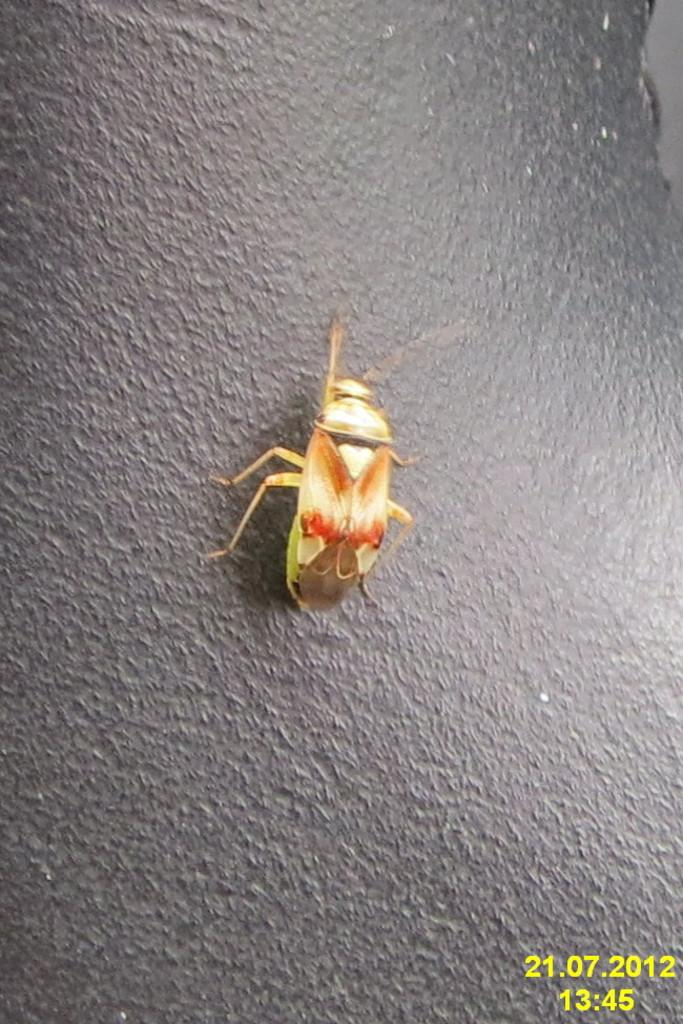What type of creature is present in the image? There is an insect in the image. Where is the insect located in the image? The insect is on an object. Is there any additional information or marking in the image? Yes, there is a watermark in the bottom right corner of the image. What type of juice is being consumed by the woman in the image? There is no woman or juice present in the image; it only features an insect on an object and a watermark in the bottom right corner. 